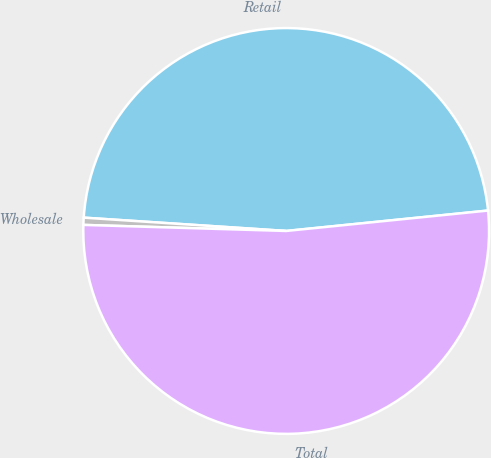Convert chart. <chart><loc_0><loc_0><loc_500><loc_500><pie_chart><fcel>Retail<fcel>Wholesale<fcel>Total<nl><fcel>47.35%<fcel>0.57%<fcel>52.08%<nl></chart> 